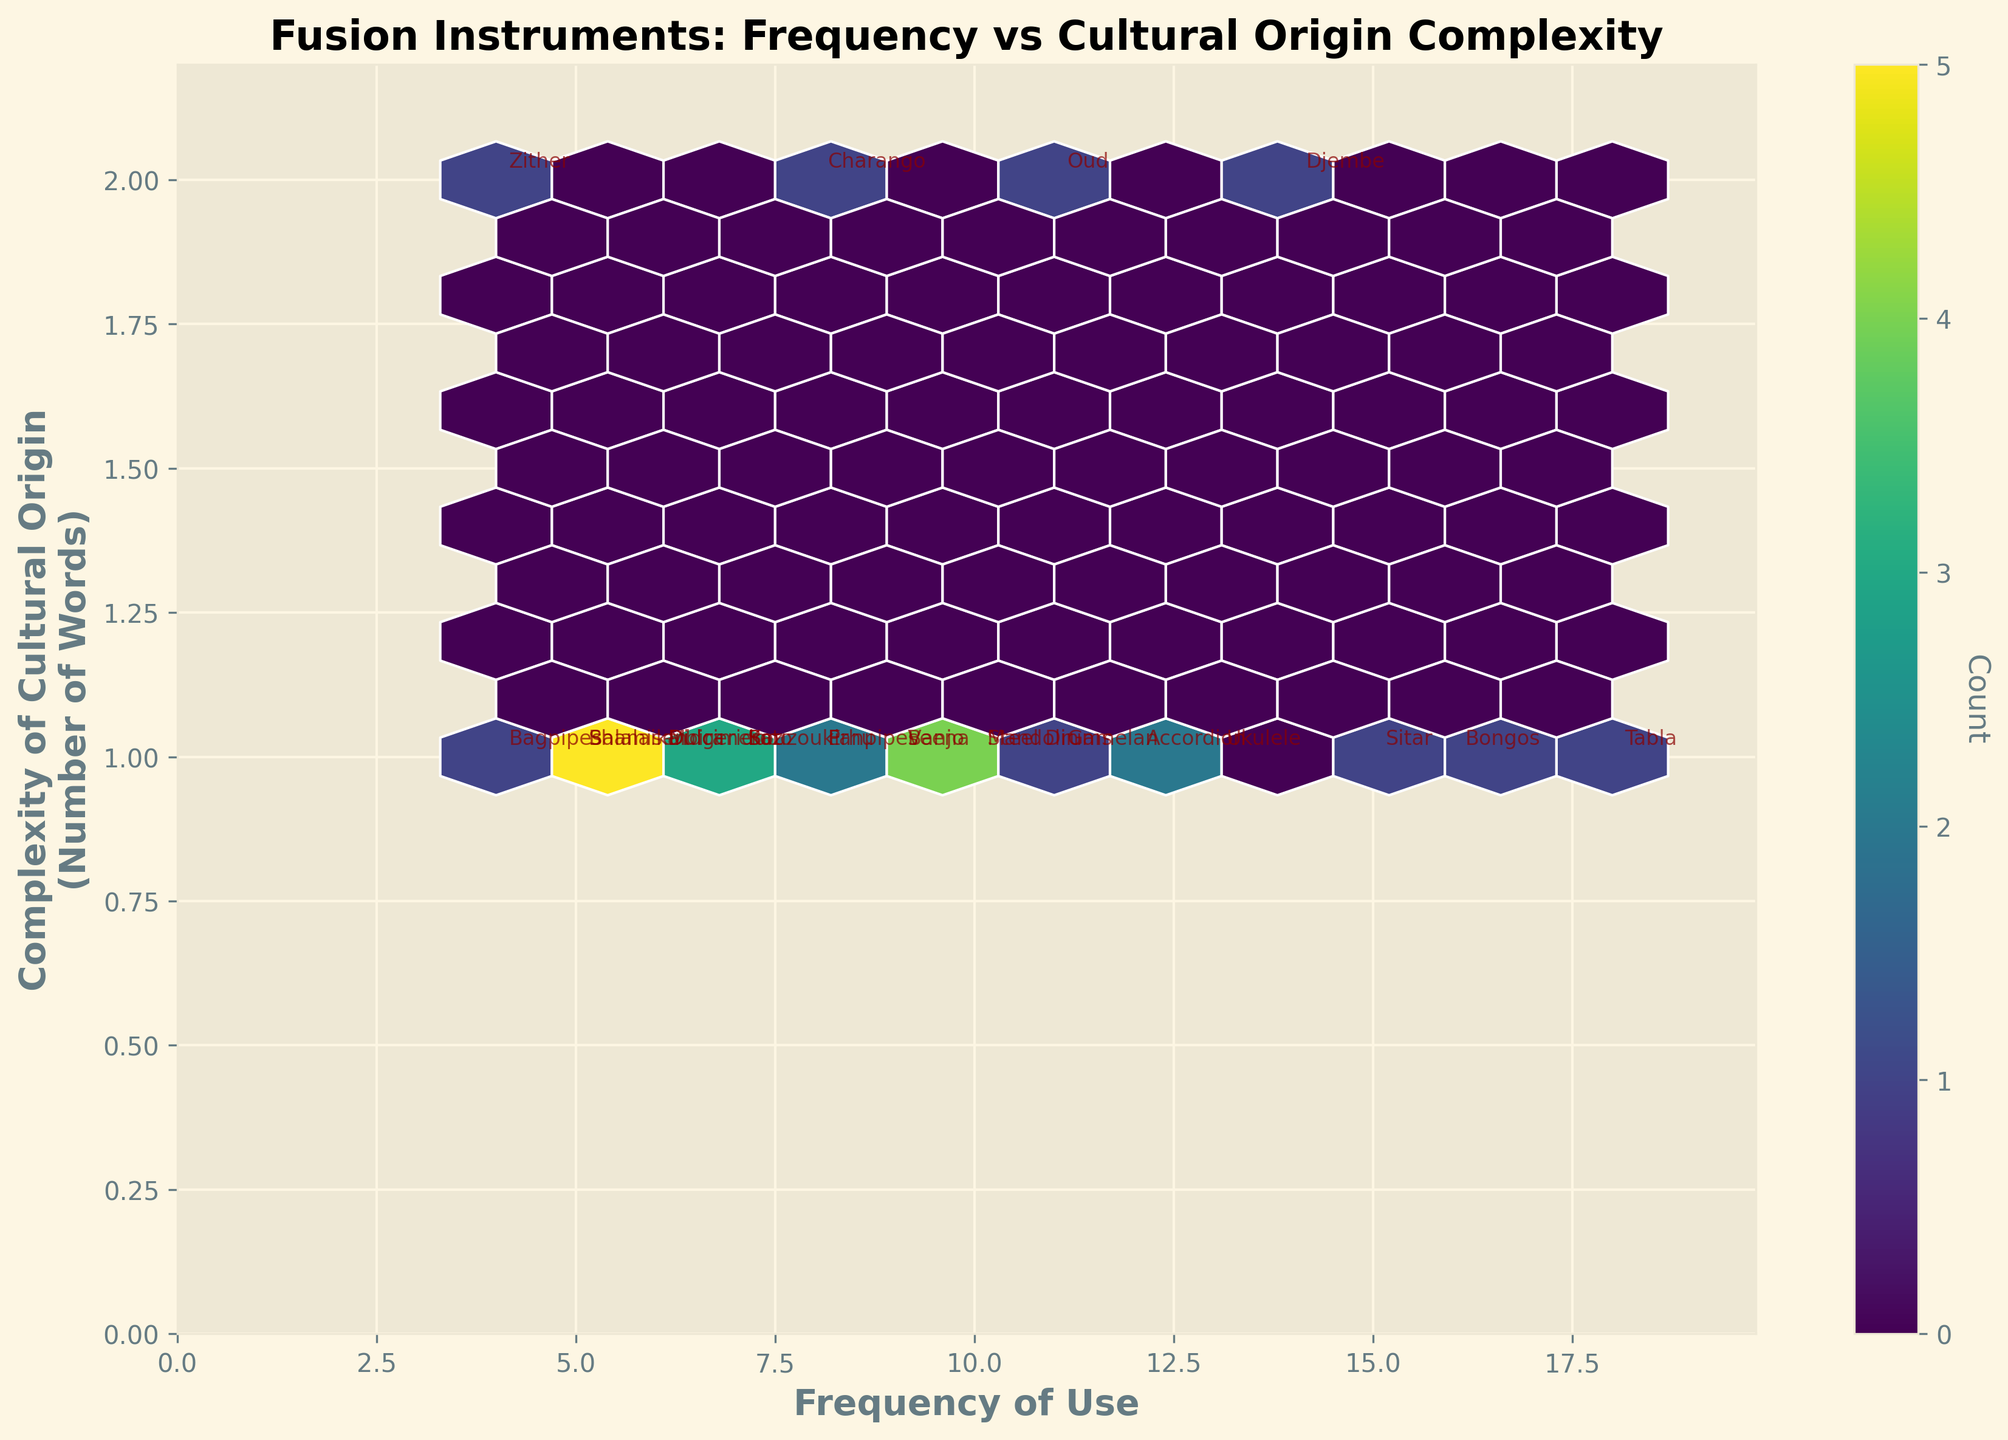What is the range of the frequency of use? The x-axis represents the 'Frequency of Use' and by looking at its limits and the labels on the axis, the frequency ranges from 0 to approximately 20.
Answer: Approximately 0 to 20 Which instrument has the highest frequency of use? By identifying the highest x-coordinate value and referring to the annotations on the plot, it is clear the Tabla (18) has the highest frequency of use.
Answer: Tabla Which instrument(s) have a cultural origin complexity equal to "3"? Complexity of cultural origin is represented on the y-axis. By looking for y-values of 3 and checking the annotations nearby, the instruments are Bagpipes and Zither.
Answer: Bagpipes, Zither How many instruments come from cultures with a single-word cultural origin? Complexity of cultural origin is shown on the y-axis. Counting the data points with a y-coordinate of 1, there are 11 such instruments.
Answer: 11 What is the average frequency of use for instruments from cultures with a complexity of 2 in their cultural origin? Find the y-values of 2 and list their corresponding x-values (frequencies): Didgeridoo (6), Balalaika (5), Charango (8), Ukulele (13), etc. Sum these (6+5+8+7 = 26) and divide by their count (4): 26/4.
Answer: 6.5 How does the frequency distribution change with increasing complexity of cultural origin? By observing the plot, one can see that data points are more densely packed at lower frequencies and complexity, and as complexity increases, the data points are more spread out and less frequent.
Answer: Frequency decreases and spreads out as complexity increases How many instruments have a frequency of use greater than 10? By examining the x-axis and counting the number of instruments with x-values greater than 10, there are 9 instruments with such frequency.
Answer: 9 What color represents the highest number of counts in the hexbin plot? In a hexbin plot, color intensity usually represents the count density in a bin. By identifying the most intense color (brightest/largest bin denoted in legend), bright yellow is the highest count.
Answer: Bright yellow 